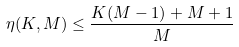Convert formula to latex. <formula><loc_0><loc_0><loc_500><loc_500>\eta ( K , M ) \leq \frac { K ( M - 1 ) + M + 1 } { M }</formula> 